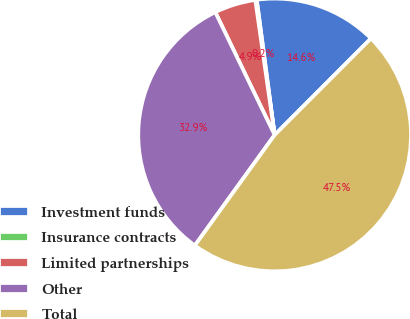<chart> <loc_0><loc_0><loc_500><loc_500><pie_chart><fcel>Investment funds<fcel>Insurance contracts<fcel>Limited partnerships<fcel>Other<fcel>Total<nl><fcel>14.58%<fcel>0.17%<fcel>4.9%<fcel>32.88%<fcel>47.46%<nl></chart> 